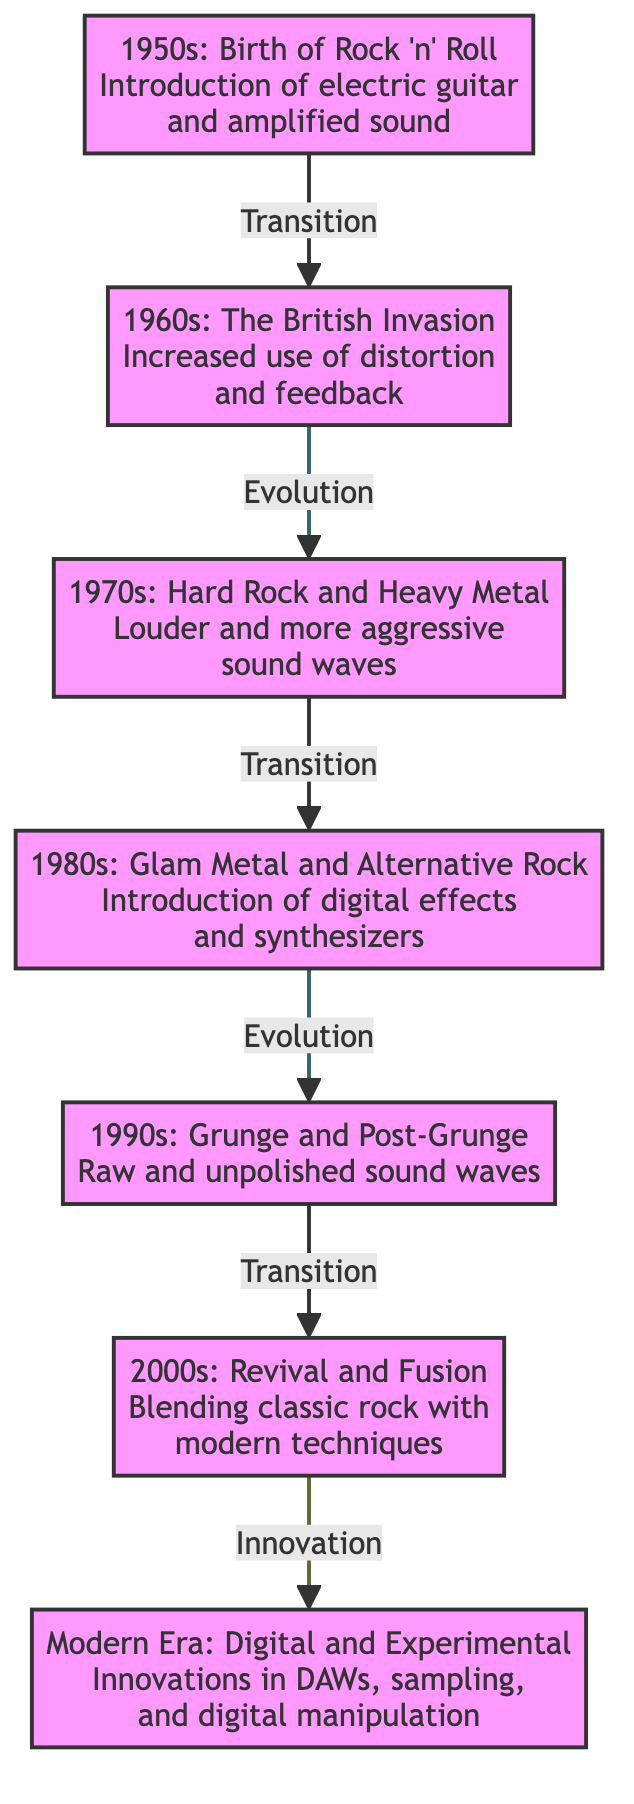What decade marks the birth of Rock 'n' Roll? The diagram explicitly states that the birth of Rock 'n' Roll occurred in the 1950s.
Answer: 1950s How many main eras of rock music evolution are depicted in the diagram? Counting the nodes in the diagram, there are seven main eras mentioned, starting from the 1950s to the Modern Era.
Answer: 7 What sound characteristic was introduced in the 1960s? The diagram indicates that the 1960s saw an increased use of distortion and feedback as sound characteristics.
Answer: Distortion and feedback What type of rock dominated the 1970s? According to the diagram, the 1970s were characterized by Hard Rock and Heavy Metal.
Answer: Hard Rock and Heavy Metal Which decade introduced digital effects in rock music? The diagram connects the introduction of digital effects to the 1980s, specifically mentioning Glam Metal and Alternative Rock.
Answer: 1980s What is the nature of the sound waves described for the 1990s? Based on the information presented, the sound waves in the 1990s are described as raw and unpolished.
Answer: Raw and unpolished Which two decades show transition relationships in the diagram? The transitions can be observed between the 1950s to 1960s and the 1970s to 1980s, indicating periods of change in music style.
Answer: 1950s to 1960s and 1970s to 1980s What type of innovation occurred in the Modern Era? The diagram classifies the Modern Era as a time for innovations in digital audio workstations, sampling, and digital manipulation.
Answer: Digital and Experimental What evolution links the 1980s and the 1990s? The evolution from the 1980s to the 1990s is described as a transition from Glam Metal and Alternative Rock to Grunge and Post-Grunge sounds.
Answer: Evolution from 1980s to 1990s 